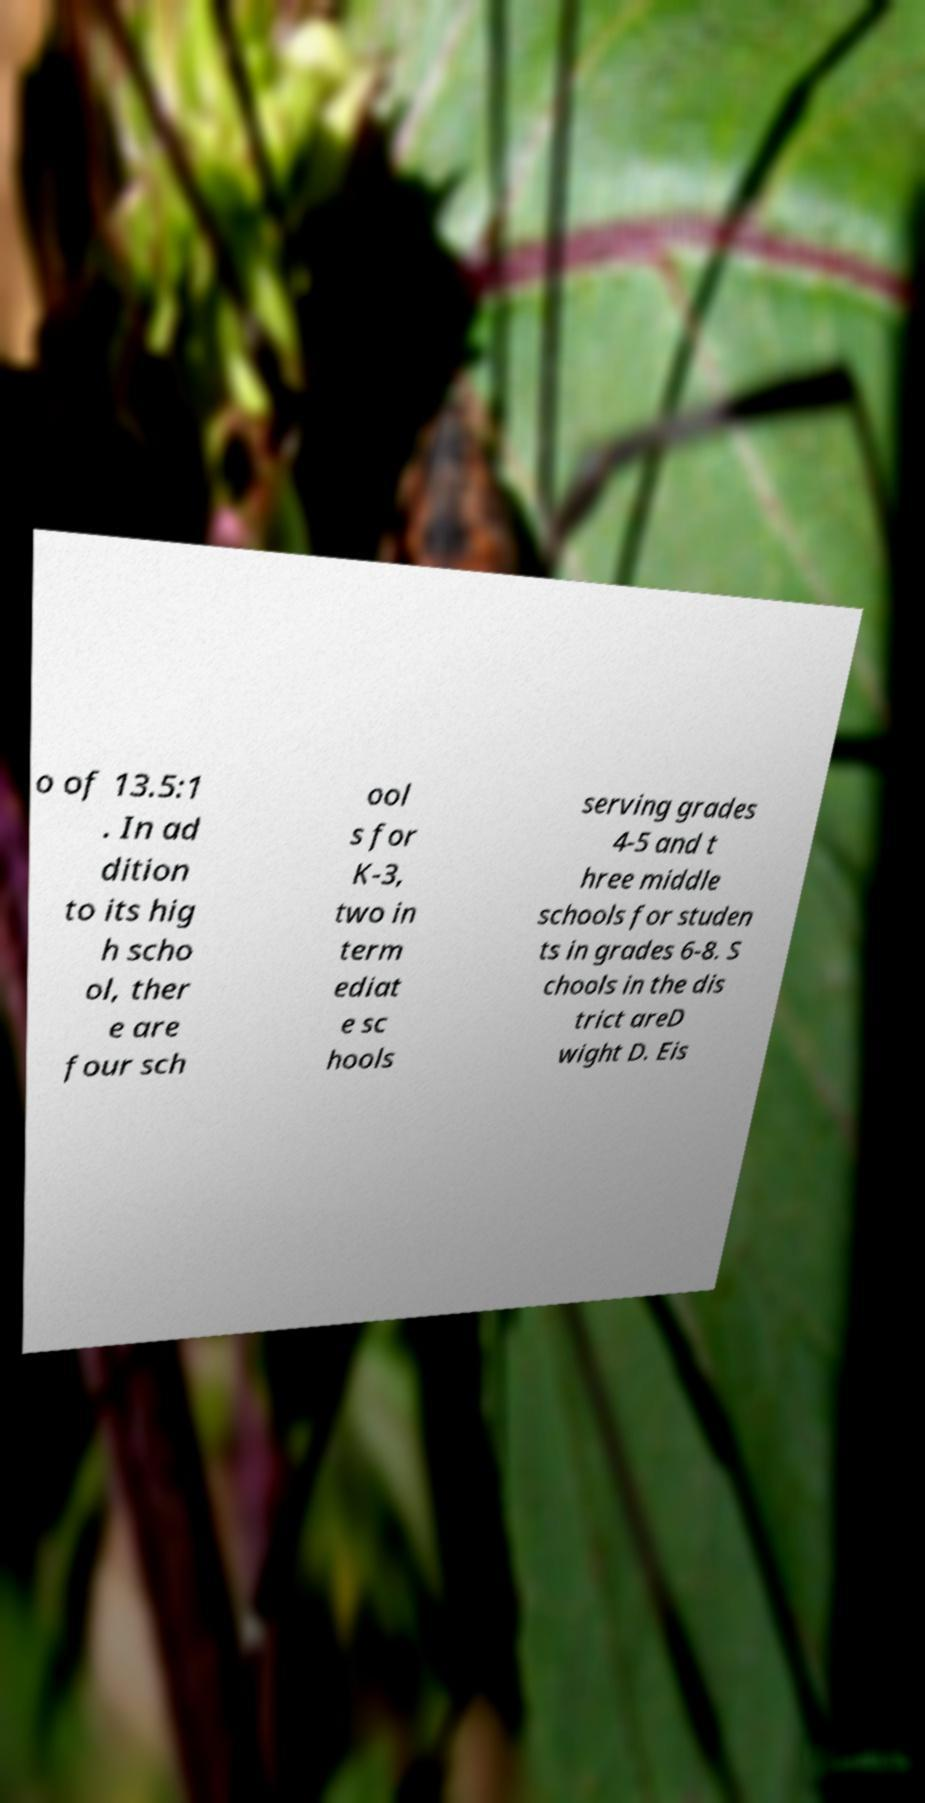Could you assist in decoding the text presented in this image and type it out clearly? o of 13.5:1 . In ad dition to its hig h scho ol, ther e are four sch ool s for K-3, two in term ediat e sc hools serving grades 4-5 and t hree middle schools for studen ts in grades 6-8. S chools in the dis trict areD wight D. Eis 